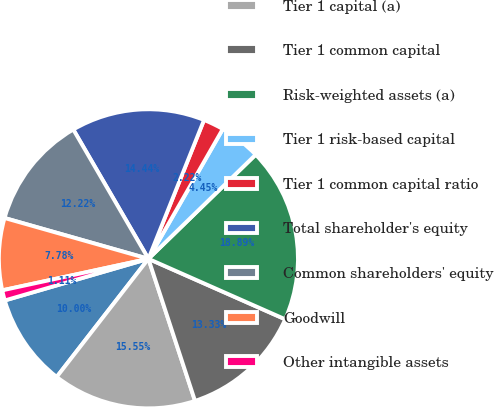Convert chart to OTSL. <chart><loc_0><loc_0><loc_500><loc_500><pie_chart><fcel>(dollar amounts in millions)<fcel>Tier 1 capital (a)<fcel>Tier 1 common capital<fcel>Risk-weighted assets (a)<fcel>Tier 1 risk-based capital<fcel>Tier 1 common capital ratio<fcel>Total shareholder's equity<fcel>Common shareholders' equity<fcel>Goodwill<fcel>Other intangible assets<nl><fcel>10.0%<fcel>15.55%<fcel>13.33%<fcel>18.89%<fcel>4.45%<fcel>2.22%<fcel>14.44%<fcel>12.22%<fcel>7.78%<fcel>1.11%<nl></chart> 